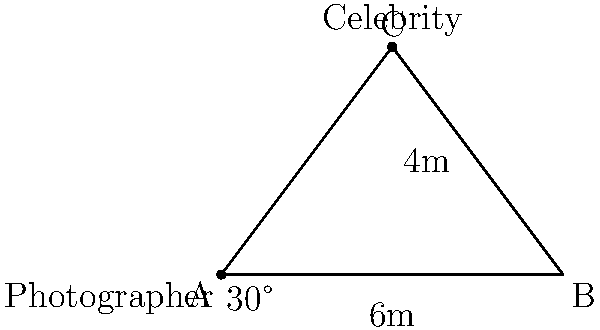As a celebrity press officer, you need to advise paparazzi on the optimal viewing angle for capturing photographs of a high-profile client. The celebrity is standing on a balcony 4 meters above ground level and 3 meters away from the building's edge. If a photographer is positioned 6 meters from the base of the building, what is the optimal angle (to the nearest degree) at which they should aim their camera for the best shot? Let's approach this step-by-step:

1) We can treat this scenario as a right-angled triangle, where:
   - The photographer is at point A (ground level)
   - The celebrity is at point C (on the balcony)
   - Point B is directly below the celebrity on ground level

2) We know:
   - AB = 6 meters (distance from photographer to building)
   - BC = 4 meters (height of balcony)
   - AC is the line of sight from photographer to celebrity

3) To find the optimal angle, we need to calculate angle CAB:

4) We can use the tangent function:

   $$\tan(\theta) = \frac{\text{opposite}}{\text{adjacent}} = \frac{BC}{AB} = \frac{4}{6}$$

5) To find $\theta$, we use the inverse tangent (arctangent) function:

   $$\theta = \arctan(\frac{4}{6})$$

6) Calculate:
   $$\theta = \arctan(0.6666...) \approx 33.69°$$

7) Rounding to the nearest degree:
   $$\theta \approx 34°$$

Therefore, the optimal angle for the photographer to aim their camera is approximately 34 degrees above the horizontal.
Answer: 34° 